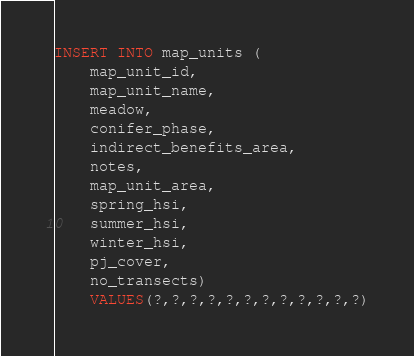<code> <loc_0><loc_0><loc_500><loc_500><_SQL_>INSERT INTO map_units (
    map_unit_id,
    map_unit_name,
    meadow,
    conifer_phase,
    indirect_benefits_area,
    notes,
    map_unit_area,
    spring_hsi,
    summer_hsi,
    winter_hsi,
    pj_cover,
    no_transects)
    VALUES(?,?,?,?,?,?,?,?,?,?,?,?)</code> 